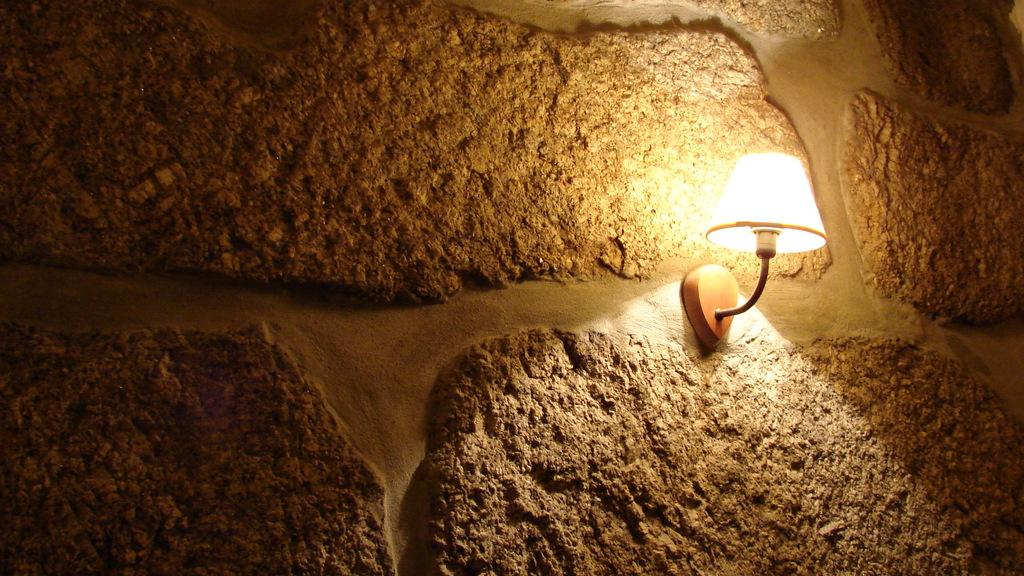What is present in the image that provides illumination? There is a light in the image. Where is the light located? The light is on a stone wall. What type of whip is being used by the friend in the image? There is no whip or friend present in the image; it only features a light on a stone wall. 